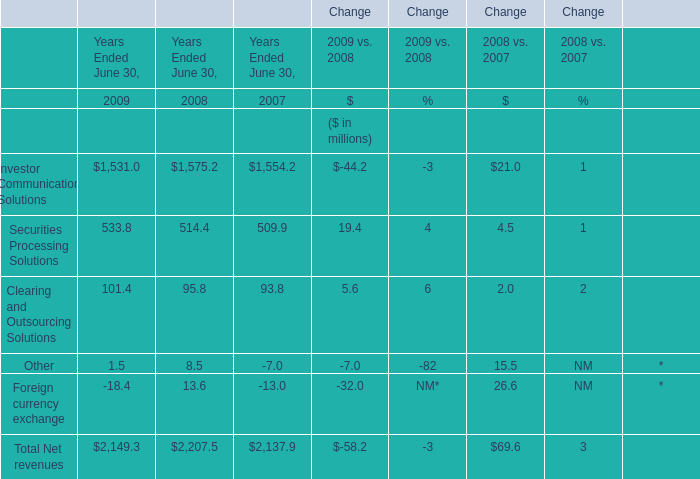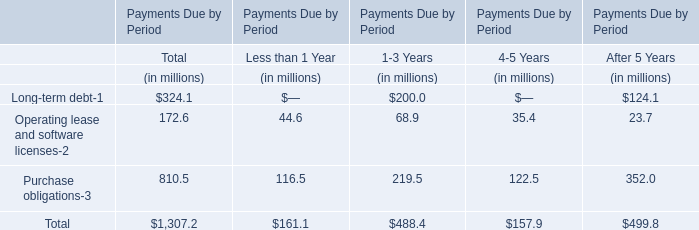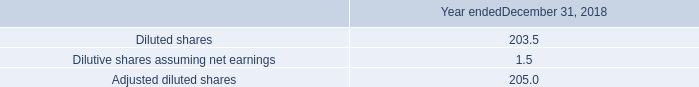what is the percent change in cash flows provided by operating activities between 2018 and 2017? 
Computations: ((1582.3 - 1747.4) / 1582.3)
Answer: -0.10434. 